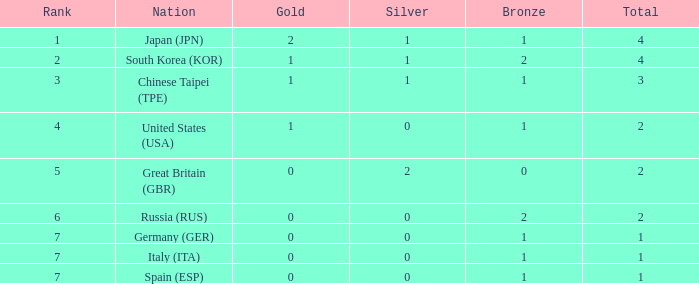What is the smallest number of gold of a country of rank 6, with 2 bronzes? None. 